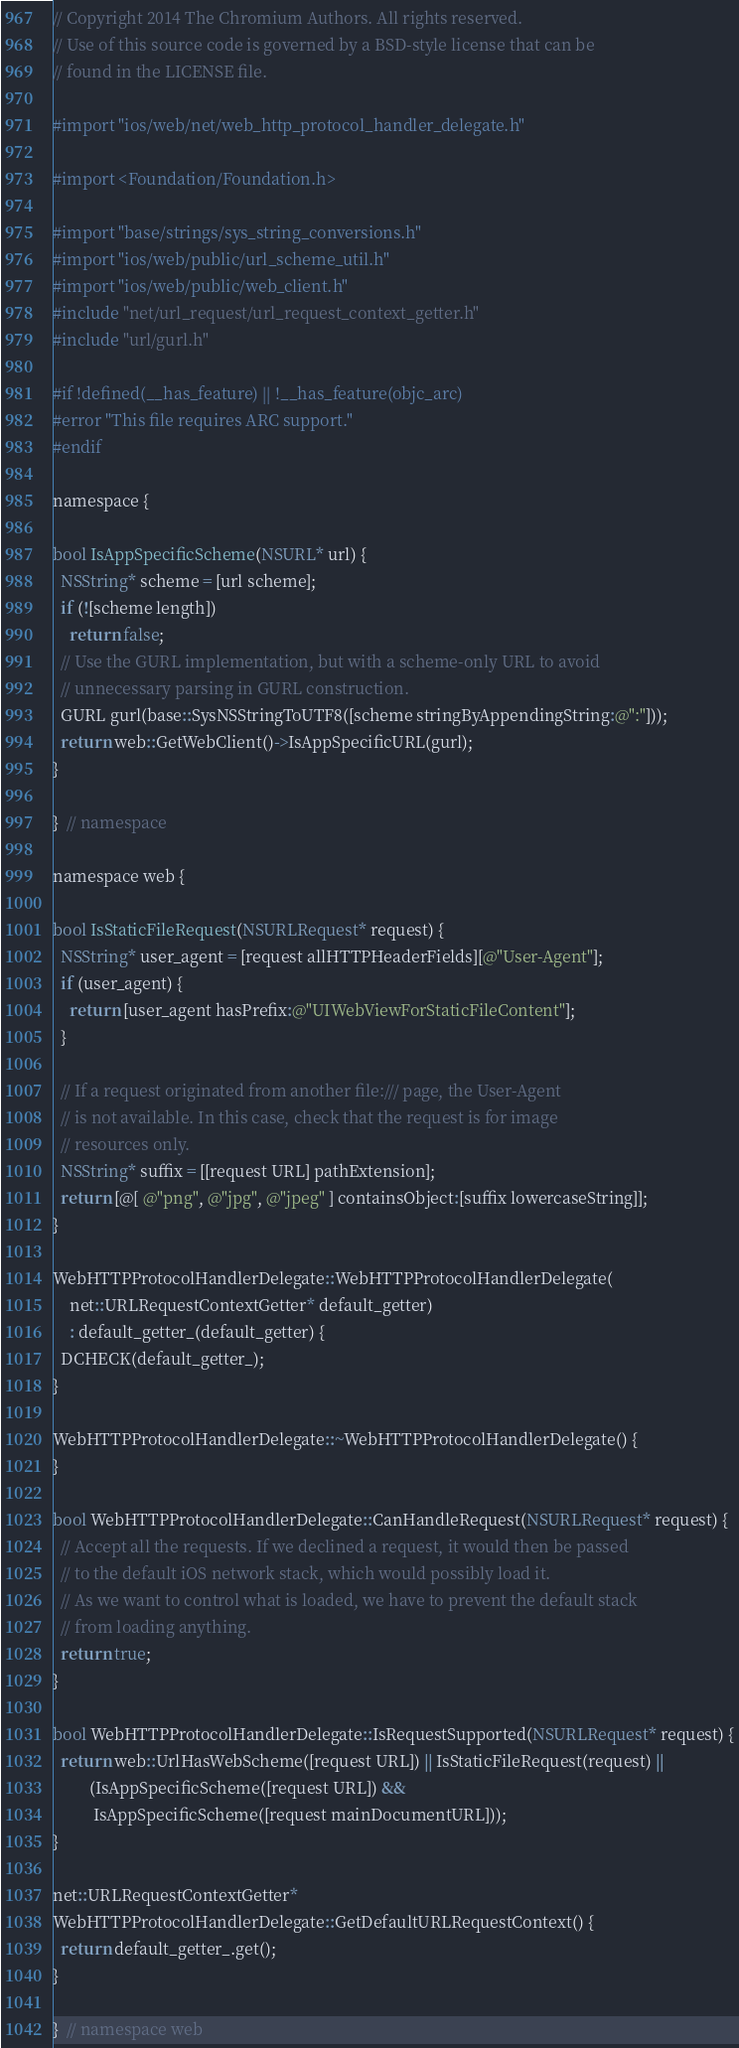<code> <loc_0><loc_0><loc_500><loc_500><_ObjectiveC_>// Copyright 2014 The Chromium Authors. All rights reserved.
// Use of this source code is governed by a BSD-style license that can be
// found in the LICENSE file.

#import "ios/web/net/web_http_protocol_handler_delegate.h"

#import <Foundation/Foundation.h>

#import "base/strings/sys_string_conversions.h"
#import "ios/web/public/url_scheme_util.h"
#import "ios/web/public/web_client.h"
#include "net/url_request/url_request_context_getter.h"
#include "url/gurl.h"

#if !defined(__has_feature) || !__has_feature(objc_arc)
#error "This file requires ARC support."
#endif

namespace {

bool IsAppSpecificScheme(NSURL* url) {
  NSString* scheme = [url scheme];
  if (![scheme length])
    return false;
  // Use the GURL implementation, but with a scheme-only URL to avoid
  // unnecessary parsing in GURL construction.
  GURL gurl(base::SysNSStringToUTF8([scheme stringByAppendingString:@":"]));
  return web::GetWebClient()->IsAppSpecificURL(gurl);
}

}  // namespace

namespace web {

bool IsStaticFileRequest(NSURLRequest* request) {
  NSString* user_agent = [request allHTTPHeaderFields][@"User-Agent"];
  if (user_agent) {
    return [user_agent hasPrefix:@"UIWebViewForStaticFileContent"];
  }

  // If a request originated from another file:/// page, the User-Agent
  // is not available. In this case, check that the request is for image
  // resources only.
  NSString* suffix = [[request URL] pathExtension];
  return [@[ @"png", @"jpg", @"jpeg" ] containsObject:[suffix lowercaseString]];
}

WebHTTPProtocolHandlerDelegate::WebHTTPProtocolHandlerDelegate(
    net::URLRequestContextGetter* default_getter)
    : default_getter_(default_getter) {
  DCHECK(default_getter_);
}

WebHTTPProtocolHandlerDelegate::~WebHTTPProtocolHandlerDelegate() {
}

bool WebHTTPProtocolHandlerDelegate::CanHandleRequest(NSURLRequest* request) {
  // Accept all the requests. If we declined a request, it would then be passed
  // to the default iOS network stack, which would possibly load it.
  // As we want to control what is loaded, we have to prevent the default stack
  // from loading anything.
  return true;
}

bool WebHTTPProtocolHandlerDelegate::IsRequestSupported(NSURLRequest* request) {
  return web::UrlHasWebScheme([request URL]) || IsStaticFileRequest(request) ||
         (IsAppSpecificScheme([request URL]) &&
          IsAppSpecificScheme([request mainDocumentURL]));
}

net::URLRequestContextGetter*
WebHTTPProtocolHandlerDelegate::GetDefaultURLRequestContext() {
  return default_getter_.get();
}

}  // namespace web
</code> 